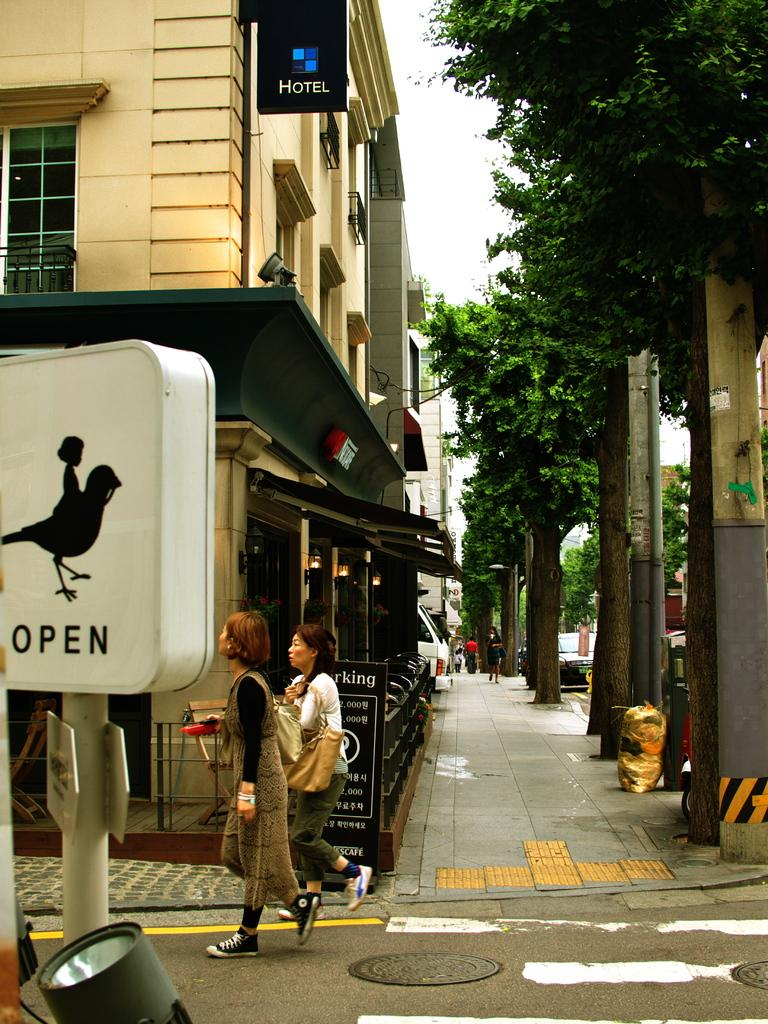What is located on the left side of the image? There is a lamp and pole on the left side of the image. What can be seen in the background of the image? There are buildings, stalls, people, trees, and a pole in the background of the image. What is visible in the sky in the background of the image? The sky is visible in the background of the image. What type of vest is being worn by the bushes in the image? There are no bushes or vests present in the image. How does the society depicted in the image function? The image does not depict a society, so it is not possible to determine how it functions. 